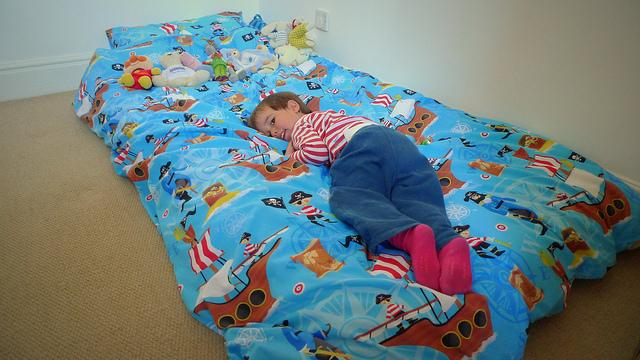Who is joining the boy on his bed? Please explain your reasoning. stuffed animals. There are stuffed animals on his bed. some children like to sleep with their toys. 